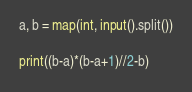<code> <loc_0><loc_0><loc_500><loc_500><_Python_>a, b = map(int, input().split())
            
print((b-a)*(b-a+1)//2-b)</code> 